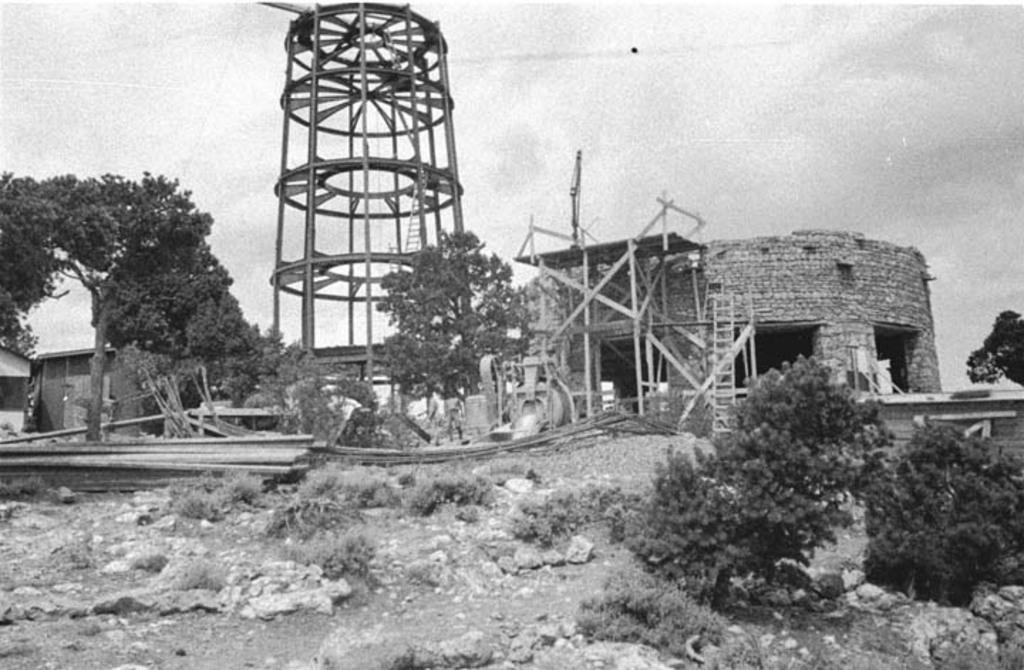What is the color scheme of the image? The image is black and white. What type of objects can be seen in the image? There are plants and construction materials in the image. What can be seen in the background of the image? The sky is visible in the background of the image. Can you tell me where the writer is sitting in the image? There is no writer present in the image. What type of spark can be seen coming from the plants in the image? There is no spark present in the image; it is a black and white image of plants and construction materials. 